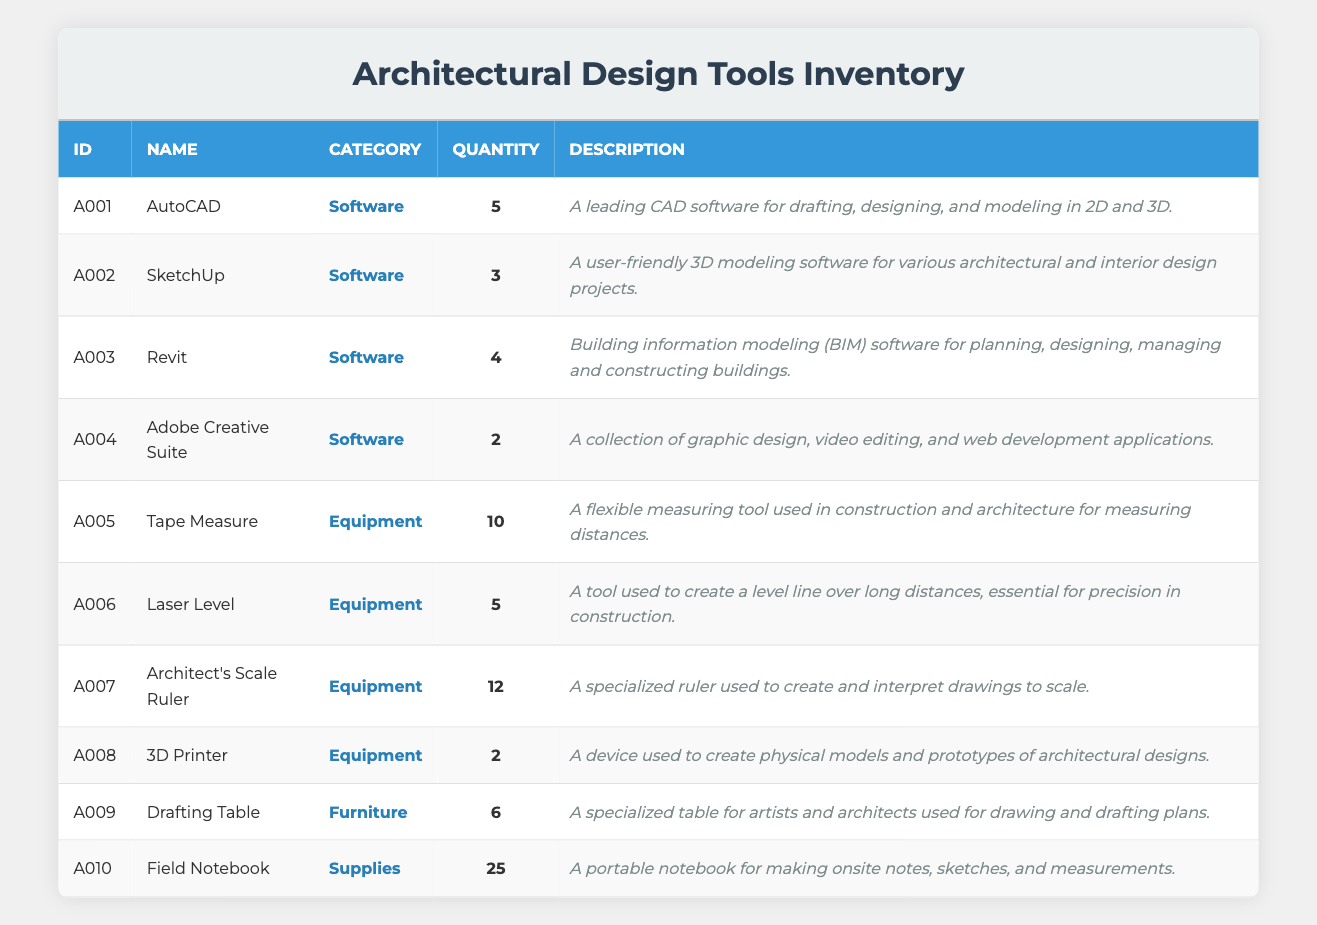What is the total quantity of equipment listed in the inventory? To find the total quantity of equipment, we need to identify the items categorized as "Equipment" and sum their quantities. The equipment items are Tape Measure (10), Laser Level (5), Architect's Scale Ruler (12), 3D Printer (2). Adding these gives us 10 + 5 + 12 + 2 = 29.
Answer: 29 Which software has the highest quantity in the inventory? The software items are AutoCAD (5), SketchUp (3), Revit (4), and Adobe Creative Suite (2). Among these, AutoCAD has the highest quantity at 5.
Answer: AutoCAD Is there an item categorized as Furniture in the inventory? There is one item categorized as Furniture: the Drafting Table. Therefore, the answer is yes.
Answer: Yes What is the total number of items available in the inventory? To find the total number of items, we sum the quantities of all items in the inventory: AutoCAD (5) + SketchUp (3) + Revit (4) + Adobe Creative Suite (2) + Tape Measure (10) + Laser Level (5) + Architect's Scale Ruler (12) + 3D Printer (2) + Drafting Table (6) + Field Notebook (25) = 69.
Answer: 69 How many more Architect's Scale Rulers are there compared to 3D Printers? The quantity of Architect's Scale Rulers is 12, and the quantity of 3D Printers is 2. To find the difference, we calculate 12 - 2 = 10.
Answer: 10 What percentage of the total inventory do the software items represent? The total quantity of software items is AutoCAD (5) + SketchUp (3) + Revit (4) + Adobe Creative Suite (2) = 14. The total quantity in the inventory is 69. To find the percentage, we calculate (14/69) * 100, which gives approximately 20.3%.
Answer: 20.3% Does the inventory include any supplies? There is one item classified as supplies: the Field Notebook. Thus, the answer is yes.
Answer: Yes Which item has the lowest quantity in the inventory? The items and their quantities are as follows: AutoCAD (5), SketchUp (3), Revit (4), Adobe Creative Suite (2), Tape Measure (10), Laser Level (5), Architect's Scale Ruler (12), 3D Printer (2), Drafting Table (6), and Field Notebook (25). The lowest quantities are for Adobe Creative Suite and 3D Printer, both with 2.
Answer: Adobe Creative Suite and 3D Printer 